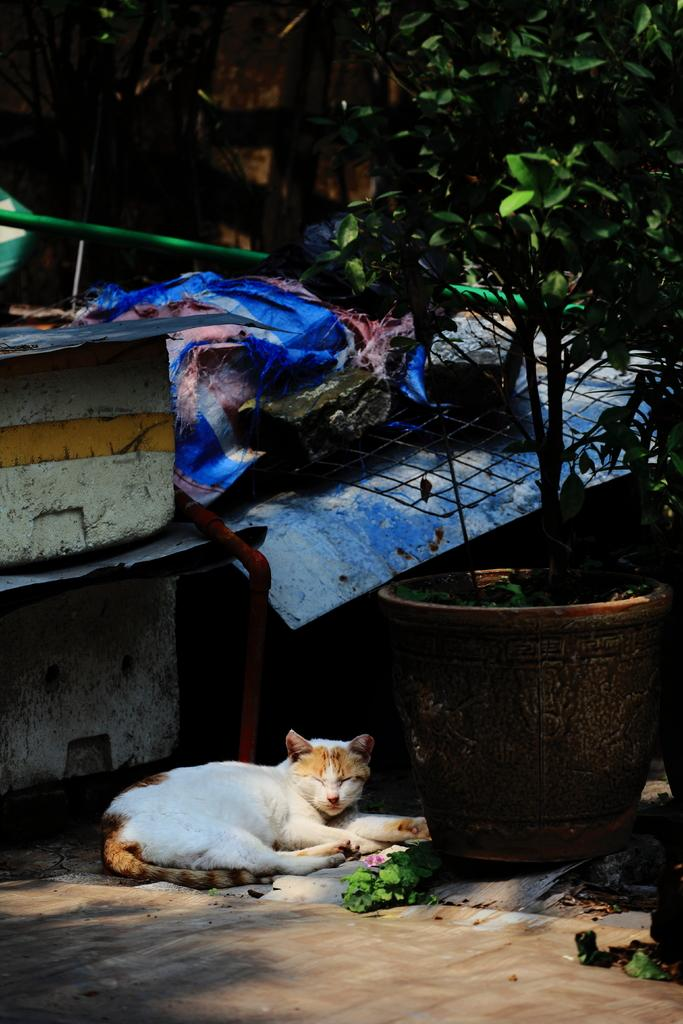What animal can be seen in the image? There is a cat laying on the ground in the image. What type of material is present in the image? There is a mesh in the image. What type of plant is visible in the image? There is a plant with a pot in the image. How many objects can be seen in the image? There are a few objects in the image. What type of clothing is present in the image? There are clothes in the image. What is the purpose of the rod in the image? There is a rod in the image, which might be used for hanging or supporting something. What can be seen in the background of the image? There is a wall in the background of the image. What type of songs can be heard coming from the record in the image? There is no record present in the image, so it's not possible to determine what songs might be heard. 